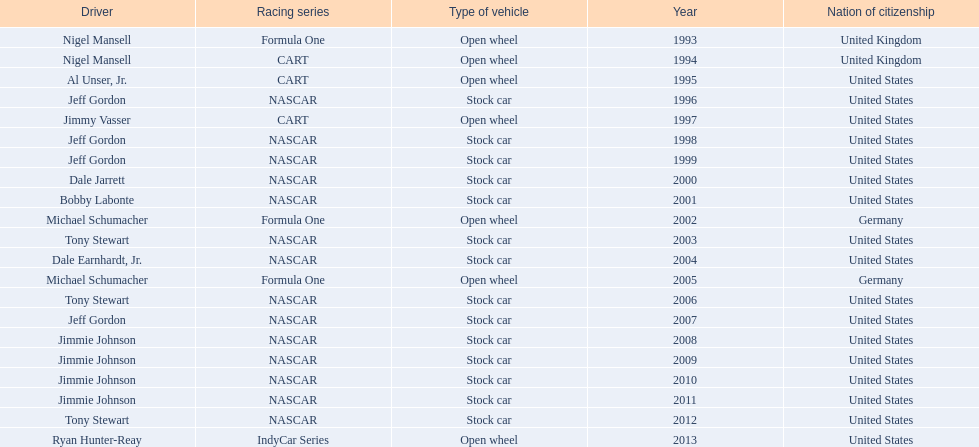Which driver, out of nigel mansell, al unser jr., michael schumacher, and jeff gordon, has just one espy award, while the others have multiple? Al Unser, Jr. 